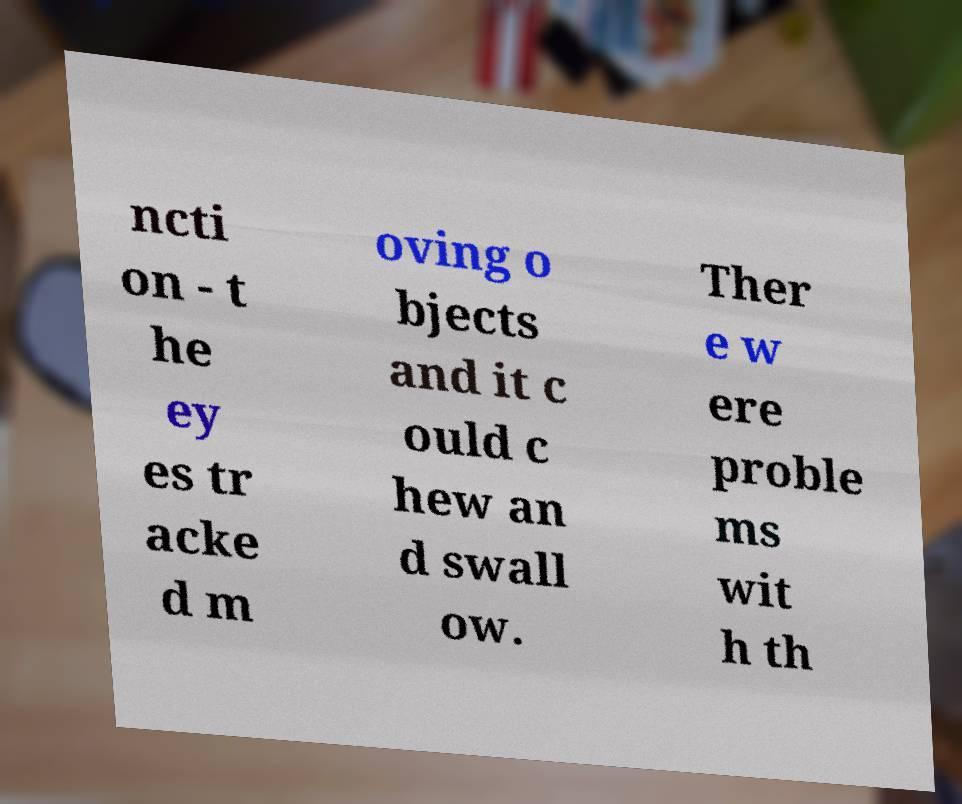Can you accurately transcribe the text from the provided image for me? ncti on - t he ey es tr acke d m oving o bjects and it c ould c hew an d swall ow. Ther e w ere proble ms wit h th 